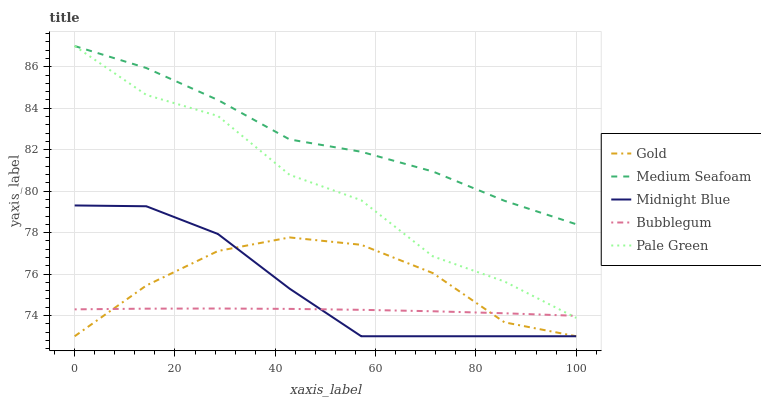Does Bubblegum have the minimum area under the curve?
Answer yes or no. Yes. Does Medium Seafoam have the maximum area under the curve?
Answer yes or no. Yes. Does Medium Seafoam have the minimum area under the curve?
Answer yes or no. No. Does Bubblegum have the maximum area under the curve?
Answer yes or no. No. Is Bubblegum the smoothest?
Answer yes or no. Yes. Is Pale Green the roughest?
Answer yes or no. Yes. Is Medium Seafoam the smoothest?
Answer yes or no. No. Is Medium Seafoam the roughest?
Answer yes or no. No. Does Gold have the lowest value?
Answer yes or no. Yes. Does Bubblegum have the lowest value?
Answer yes or no. No. Does Medium Seafoam have the highest value?
Answer yes or no. Yes. Does Bubblegum have the highest value?
Answer yes or no. No. Is Gold less than Pale Green?
Answer yes or no. Yes. Is Medium Seafoam greater than Midnight Blue?
Answer yes or no. Yes. Does Bubblegum intersect Midnight Blue?
Answer yes or no. Yes. Is Bubblegum less than Midnight Blue?
Answer yes or no. No. Is Bubblegum greater than Midnight Blue?
Answer yes or no. No. Does Gold intersect Pale Green?
Answer yes or no. No. 